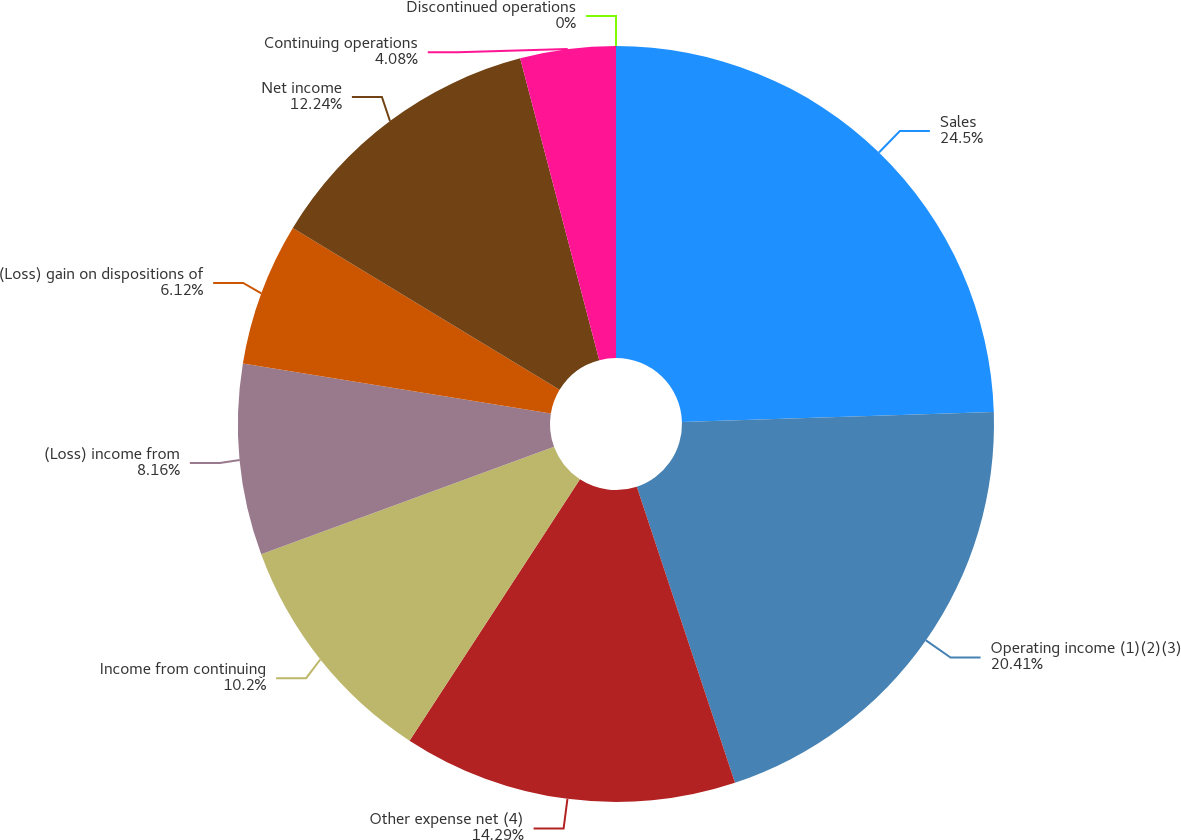Convert chart. <chart><loc_0><loc_0><loc_500><loc_500><pie_chart><fcel>Sales<fcel>Operating income (1)(2)(3)<fcel>Other expense net (4)<fcel>Income from continuing<fcel>(Loss) income from<fcel>(Loss) gain on dispositions of<fcel>Net income<fcel>Continuing operations<fcel>Discontinued operations<nl><fcel>24.49%<fcel>20.41%<fcel>14.29%<fcel>10.2%<fcel>8.16%<fcel>6.12%<fcel>12.24%<fcel>4.08%<fcel>0.0%<nl></chart> 